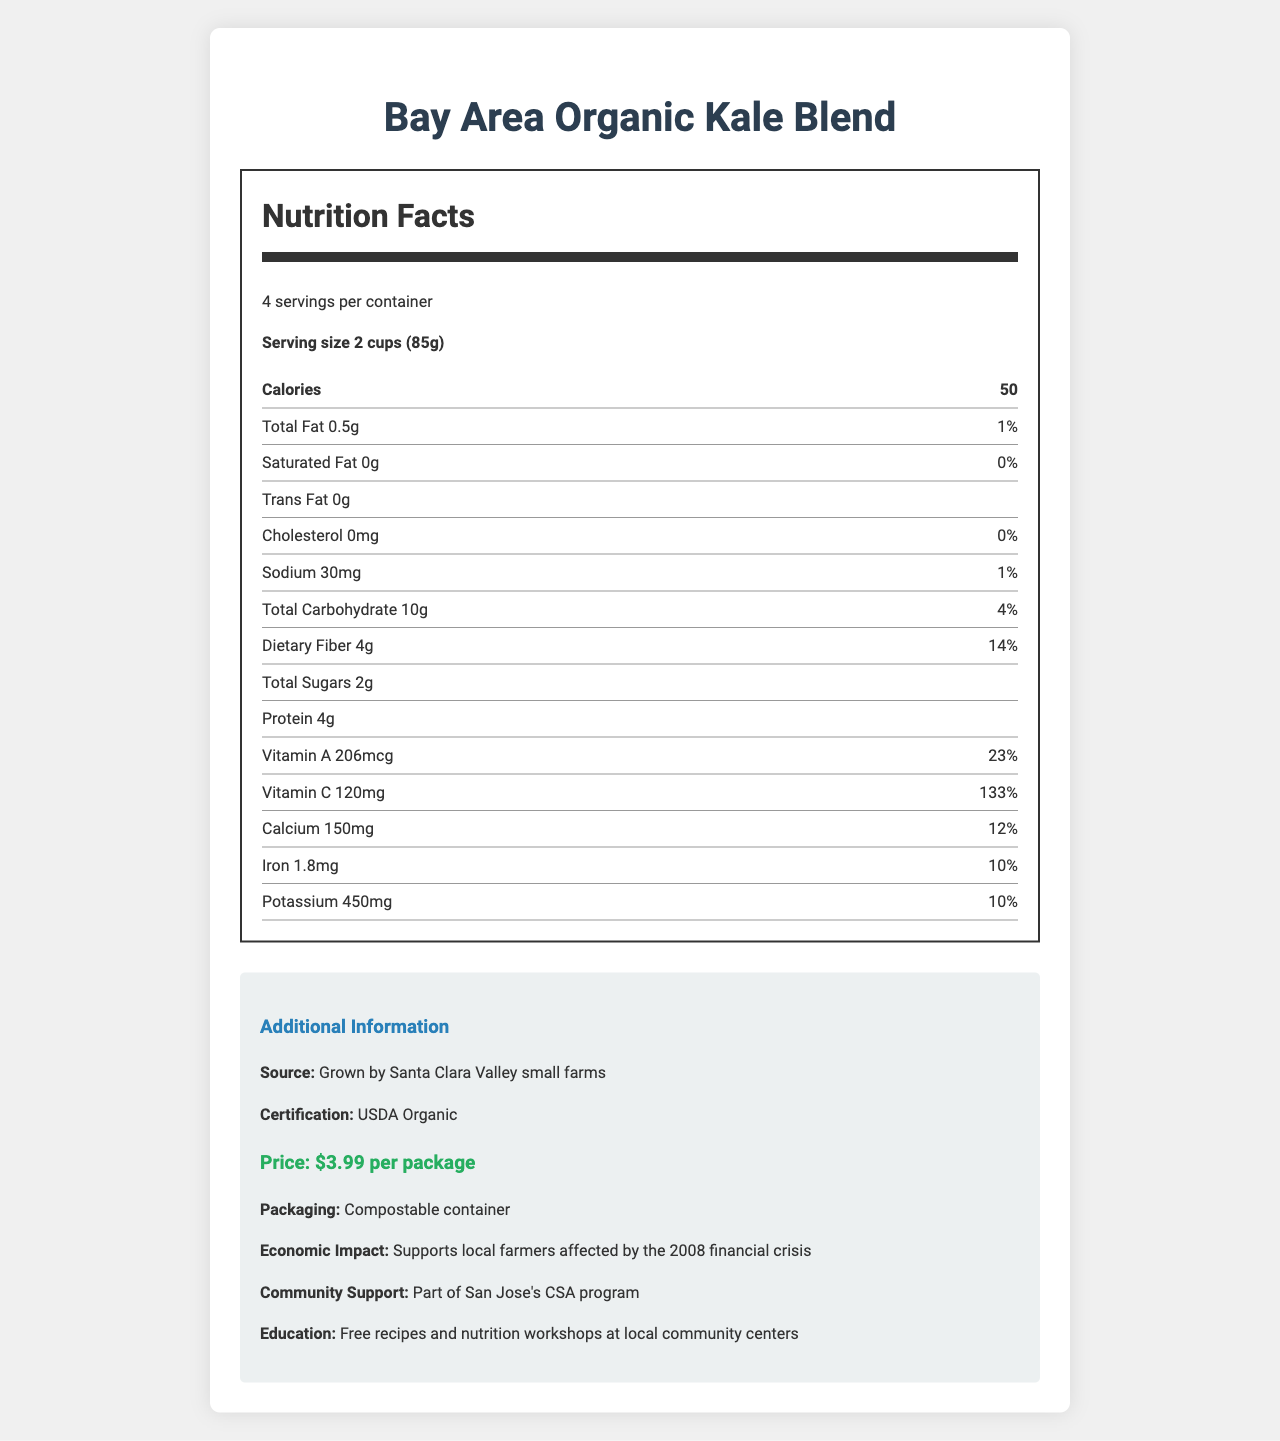what is the serving size of the Bay Area Organic Kale Blend? The document specifies a serving size of 2 cups (85g) right under the nutrition facts header.
Answer: 2 cups (85g) how many calories are there per serving? The document lists the calorie content per serving as 50.
Answer: 50 calories what percentage of the daily value of Vitamin C does one serving provide? The Vitamin C content shows 120mg, which is 133% of the daily value.
Answer: 133% how much does the Bay Area Organic Kale Blend cost per package? The price is listed in the additional information section as $3.99 per package.
Answer: $3.99 where is the Bay Area Organic Kale Blend grown? The source is indicated as being grown by Santa Clara Valley small farms in the additional information.
Answer: Santa Clara Valley small farms does one serving of this kale blend contain any trans fat? The nutrition facts state that the trans fat content is 0g.
Answer: No how much protein is in one serving? (i) 2g (ii) 4g (iii) 6g The document specifies that one serving contains 4g of protein.
Answer: (ii) 4g what is the percentage of daily value for dietary fiber in one serving? A. 10% B. 14% C. 20% D. 25% The percentage of daily value for dietary fiber is listed as 14%.
Answer: B is the packaging eco-friendly? The additional information section notes that the packaging is compostable, indicating it is eco-friendly.
Answer: Yes summarize the main idea of the document. The document includes comprehensive nutritional facts about the kale blend, emphasizing its high nutrient density, local production, affordability, and positive economic and community impact.
Answer: The document provides detailed nutritional information about the Bay Area Organic Kale Blend, including serving size, calories, and nutrient content, along with additional details on its local, organic sourcing, eco-friendly packaging, affordable price, and its support for local farmers and community programs. what are the benefits to local farmers? The document mentions in the additional information that purchasing this product supports local farmers affected by the 2008 financial crisis.
Answer: Supports local farmers affected by the 2008 financial crisis how much daily value of calcium is provided per serving? The calcium content per serving is listed as 150mg, which is 12% of the daily value.
Answer: 12% how many senators are there in the U.S. Senate? The document is solely about the nutritional and additional information of the kale blend and does not provide any information regarding the U.S. Senate.
Answer: Cannot be determined 